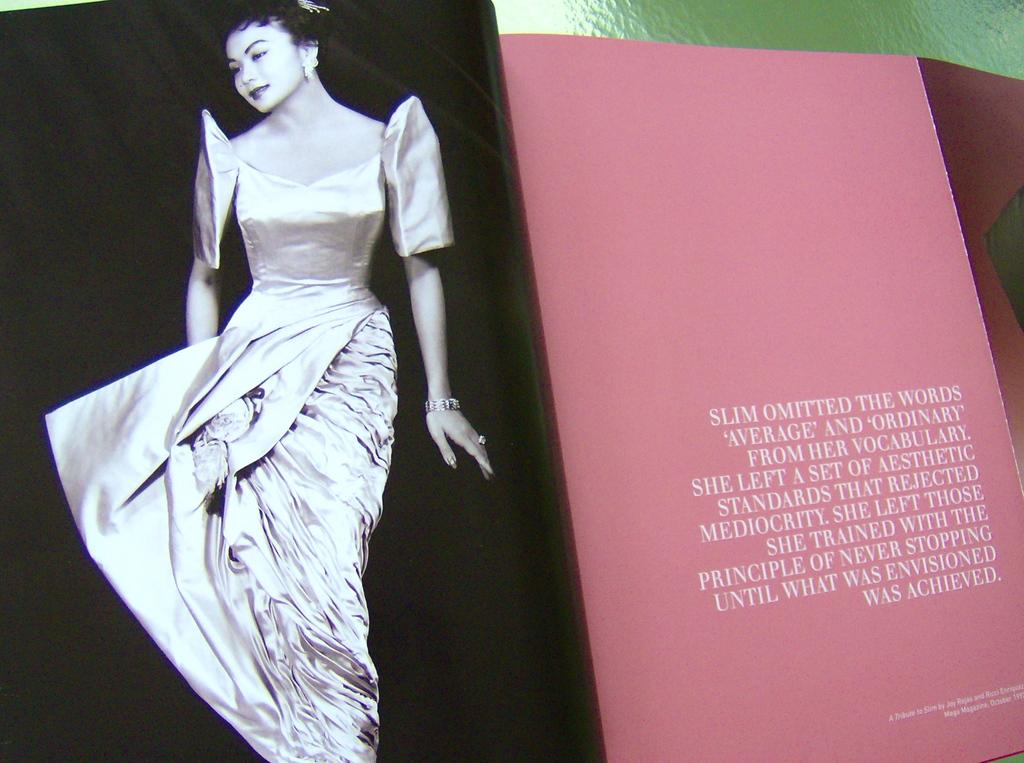What can be seen on the left side of the image? There is a photograph on the left side of the image. What is present on the right side of the image? There is text on a paper on the right side of the image. What type of structure is visible at the top of the image? There appears to be a wall at the top of the image. Are there any branches visible in the image? There are no branches present in the image. Can you see any cattle in the image? There are no cattle present in the image. 